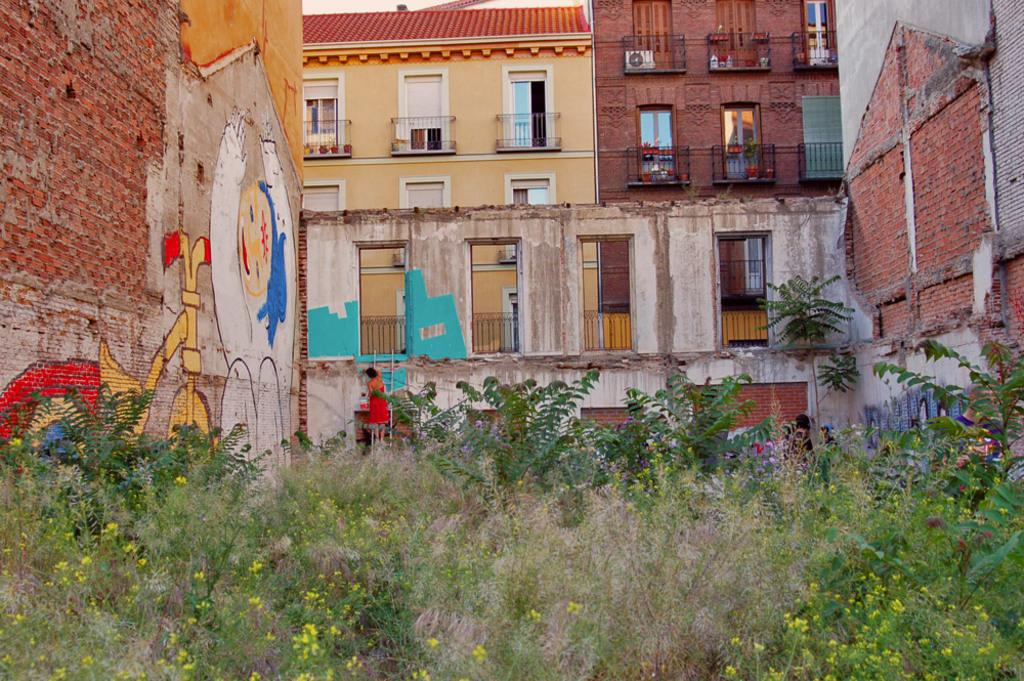What type of structures can be seen in the image? There are buildings in the image. What architectural feature is present in the image? There is a railing in the image. What type of vegetation is visible in the image? There are trees and plants in the image. Where is the painting located in the image? The painting is on the wall, which is on the left side of the image. How many oranges are hanging from the trees in the image? There are no oranges present in the image; it features trees and plants, but no fruit is visible. What type of paint is used for the painting on the wall? The provided facts do not mention the type of paint used for the painting on the wall. 